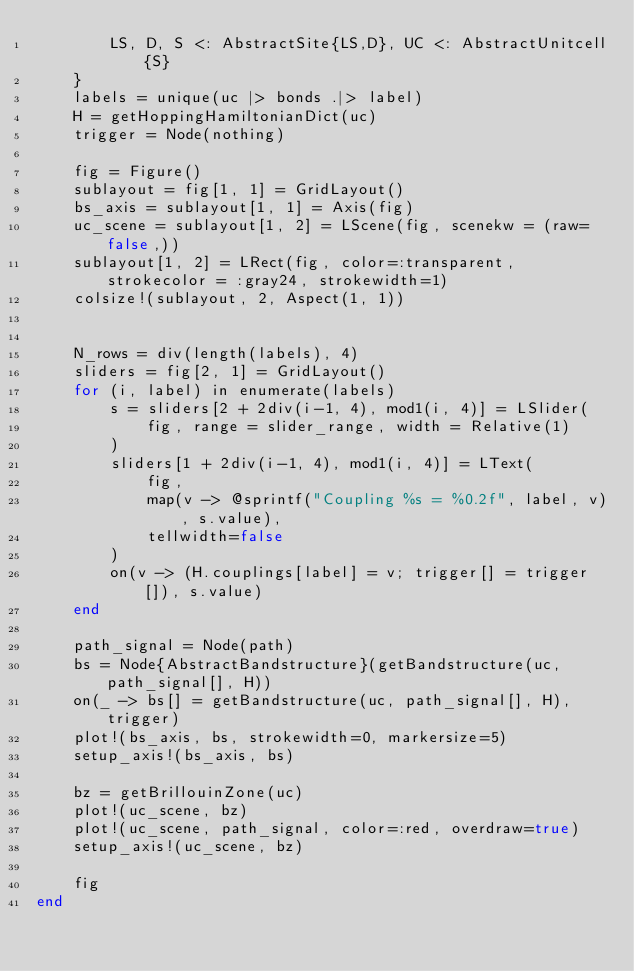Convert code to text. <code><loc_0><loc_0><loc_500><loc_500><_Julia_>        LS, D, S <: AbstractSite{LS,D}, UC <: AbstractUnitcell{S}
    }
    labels = unique(uc |> bonds .|> label)
    H = getHoppingHamiltonianDict(uc)
    trigger = Node(nothing)

    fig = Figure()
    sublayout = fig[1, 1] = GridLayout()
    bs_axis = sublayout[1, 1] = Axis(fig)
    uc_scene = sublayout[1, 2] = LScene(fig, scenekw = (raw=false,))
    sublayout[1, 2] = LRect(fig, color=:transparent, strokecolor = :gray24, strokewidth=1)
    colsize!(sublayout, 2, Aspect(1, 1))


    N_rows = div(length(labels), 4)
    sliders = fig[2, 1] = GridLayout()
    for (i, label) in enumerate(labels)
        s = sliders[2 + 2div(i-1, 4), mod1(i, 4)] = LSlider(
            fig, range = slider_range, width = Relative(1)
        )
        sliders[1 + 2div(i-1, 4), mod1(i, 4)] = LText(
            fig,
            map(v -> @sprintf("Coupling %s = %0.2f", label, v), s.value),
            tellwidth=false
        )
        on(v -> (H.couplings[label] = v; trigger[] = trigger[]), s.value)
    end

    path_signal = Node(path)
    bs = Node{AbstractBandstructure}(getBandstructure(uc, path_signal[], H))
    on(_ -> bs[] = getBandstructure(uc, path_signal[], H), trigger)
    plot!(bs_axis, bs, strokewidth=0, markersize=5)
    setup_axis!(bs_axis, bs)

    bz = getBrillouinZone(uc)
    plot!(uc_scene, bz)
    plot!(uc_scene, path_signal, color=:red, overdraw=true)
    setup_axis!(uc_scene, bz)

    fig
end
</code> 